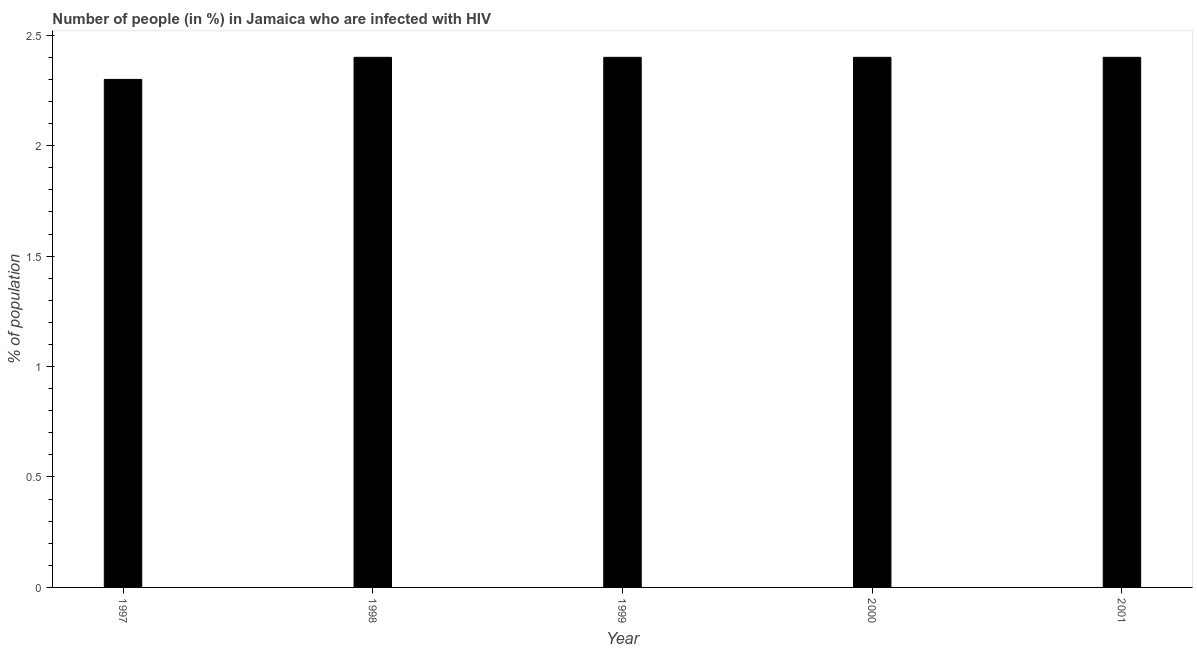What is the title of the graph?
Make the answer very short. Number of people (in %) in Jamaica who are infected with HIV. What is the label or title of the Y-axis?
Your answer should be very brief. % of population. Across all years, what is the maximum number of people infected with hiv?
Your answer should be compact. 2.4. Across all years, what is the minimum number of people infected with hiv?
Give a very brief answer. 2.3. In which year was the number of people infected with hiv minimum?
Ensure brevity in your answer.  1997. What is the sum of the number of people infected with hiv?
Make the answer very short. 11.9. What is the average number of people infected with hiv per year?
Offer a very short reply. 2.38. In how many years, is the number of people infected with hiv greater than 1.7 %?
Provide a succinct answer. 5. Do a majority of the years between 2001 and 1997 (inclusive) have number of people infected with hiv greater than 1.3 %?
Your answer should be very brief. Yes. Is the difference between the number of people infected with hiv in 1997 and 1999 greater than the difference between any two years?
Give a very brief answer. Yes. What is the difference between the highest and the lowest number of people infected with hiv?
Give a very brief answer. 0.1. How many bars are there?
Provide a succinct answer. 5. What is the difference between two consecutive major ticks on the Y-axis?
Make the answer very short. 0.5. Are the values on the major ticks of Y-axis written in scientific E-notation?
Keep it short and to the point. No. What is the % of population of 1997?
Keep it short and to the point. 2.3. What is the % of population of 1998?
Your answer should be compact. 2.4. What is the % of population of 1999?
Keep it short and to the point. 2.4. What is the % of population in 2000?
Provide a short and direct response. 2.4. What is the difference between the % of population in 1997 and 1998?
Your response must be concise. -0.1. What is the difference between the % of population in 1997 and 1999?
Your response must be concise. -0.1. What is the difference between the % of population in 1998 and 2001?
Offer a very short reply. 0. What is the difference between the % of population in 2000 and 2001?
Give a very brief answer. 0. What is the ratio of the % of population in 1997 to that in 1998?
Offer a very short reply. 0.96. What is the ratio of the % of population in 1997 to that in 1999?
Provide a succinct answer. 0.96. What is the ratio of the % of population in 1997 to that in 2000?
Your answer should be very brief. 0.96. What is the ratio of the % of population in 1997 to that in 2001?
Ensure brevity in your answer.  0.96. What is the ratio of the % of population in 1998 to that in 2000?
Give a very brief answer. 1. What is the ratio of the % of population in 1998 to that in 2001?
Your answer should be very brief. 1. What is the ratio of the % of population in 1999 to that in 2001?
Offer a very short reply. 1. What is the ratio of the % of population in 2000 to that in 2001?
Keep it short and to the point. 1. 